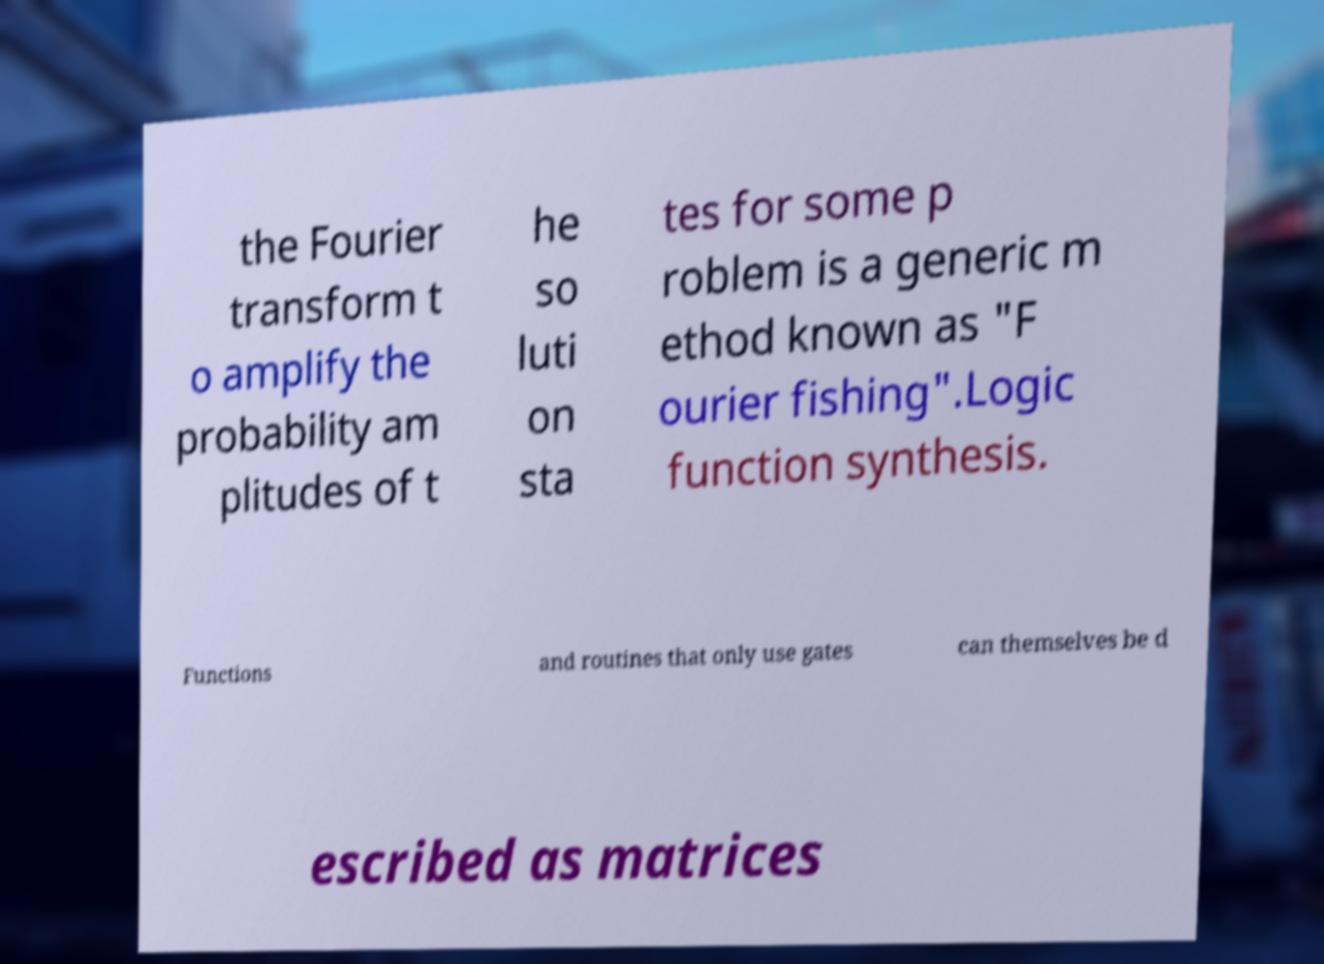Could you assist in decoding the text presented in this image and type it out clearly? the Fourier transform t o amplify the probability am plitudes of t he so luti on sta tes for some p roblem is a generic m ethod known as "F ourier fishing".Logic function synthesis. Functions and routines that only use gates can themselves be d escribed as matrices 